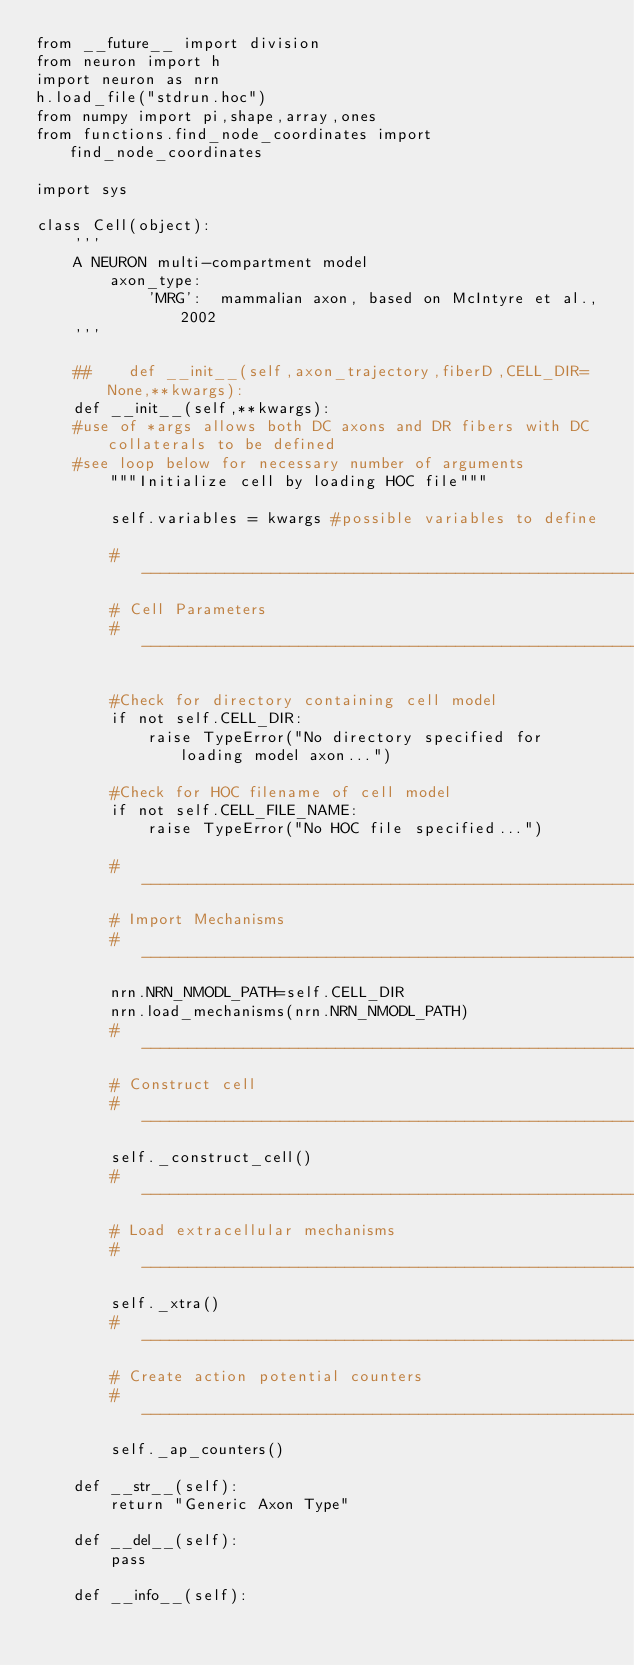Convert code to text. <code><loc_0><loc_0><loc_500><loc_500><_Python_>from __future__ import division
from neuron import h
import neuron as nrn
h.load_file("stdrun.hoc")
from numpy import pi,shape,array,ones
from functions.find_node_coordinates import find_node_coordinates

import sys

class Cell(object):
    '''
    A NEURON multi-compartment model
        axon_type:
            'MRG':  mammalian axon, based on McIntyre et al., 2002
    '''

    ##    def __init__(self,axon_trajectory,fiberD,CELL_DIR=None,**kwargs):
    def __init__(self,**kwargs):
    #use of *args allows both DC axons and DR fibers with DC collaterals to be defined
    #see loop below for necessary number of arguments
        """Initialize cell by loading HOC file"""

        self.variables = kwargs #possible variables to define

        #-----------------------------------------------------------------------
        # Cell Parameters
        #-----------------------------------------------------------------------
 
        #Check for directory containing cell model
        if not self.CELL_DIR:
            raise TypeError("No directory specified for loading model axon...")

        #Check for HOC filename of cell model
        if not self.CELL_FILE_NAME:
            raise TypeError("No HOC file specified...")

        #-----------------------------------------------------------------------
        # Import Mechanisms
        #-----------------------------------------------------------------------
        nrn.NRN_NMODL_PATH=self.CELL_DIR
        nrn.load_mechanisms(nrn.NRN_NMODL_PATH)
        #----------------------------------------------------------------------
        # Construct cell
        #-----------------------------------------------------------------------
        self._construct_cell()
        #-----------------------------------------------------------------------
        # Load extracellular mechanisms
        #-----------------------------------------------------------------------
        self._xtra()
        #-----------------------------------------------------------------------
        # Create action potential counters
        #-----------------------------------------------------------------------
        self._ap_counters()

    def __str__(self):
        return "Generic Axon Type"

    def __del__(self):
        pass

    def __info__(self):</code> 